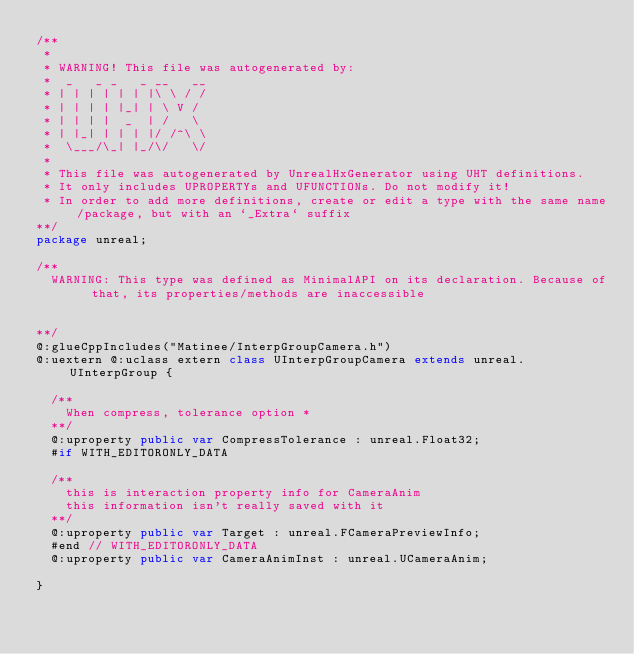<code> <loc_0><loc_0><loc_500><loc_500><_Haxe_>/**
 * 
 * WARNING! This file was autogenerated by: 
 *  _   _ _   _ __   __ 
 * | | | | | | |\ \ / / 
 * | | | | |_| | \ V /  
 * | | | |  _  | /   \  
 * | |_| | | | |/ /^\ \ 
 *  \___/\_| |_/\/   \/ 
 * 
 * This file was autogenerated by UnrealHxGenerator using UHT definitions.
 * It only includes UPROPERTYs and UFUNCTIONs. Do not modify it!
 * In order to add more definitions, create or edit a type with the same name/package, but with an `_Extra` suffix
**/
package unreal;

/**
  WARNING: This type was defined as MinimalAPI on its declaration. Because of that, its properties/methods are inaccessible
  
  
**/
@:glueCppIncludes("Matinee/InterpGroupCamera.h")
@:uextern @:uclass extern class UInterpGroupCamera extends unreal.UInterpGroup {
  
  /**
    When compress, tolerance option *
  **/
  @:uproperty public var CompressTolerance : unreal.Float32;
  #if WITH_EDITORONLY_DATA
  
  /**
    this is interaction property info for CameraAnim
    this information isn't really saved with it
  **/
  @:uproperty public var Target : unreal.FCameraPreviewInfo;
  #end // WITH_EDITORONLY_DATA
  @:uproperty public var CameraAnimInst : unreal.UCameraAnim;
  
}
</code> 